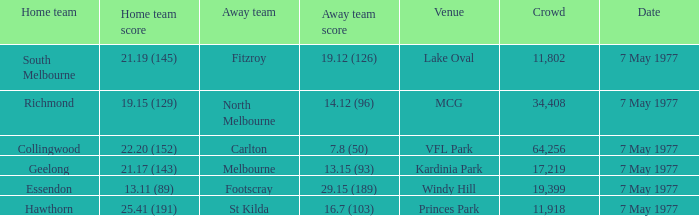Name the venue with a home team of geelong Kardinia Park. 